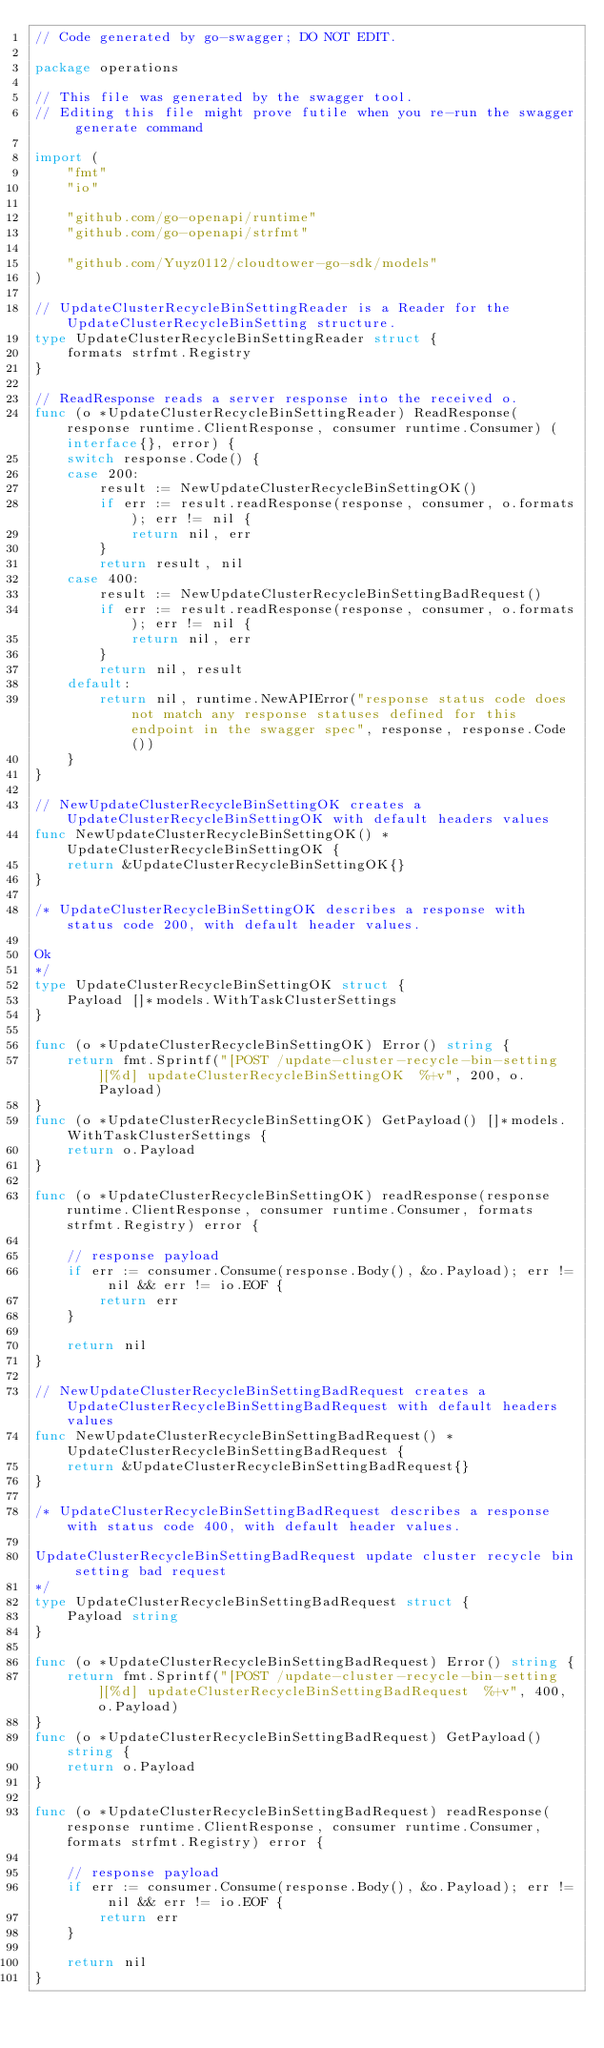<code> <loc_0><loc_0><loc_500><loc_500><_Go_>// Code generated by go-swagger; DO NOT EDIT.

package operations

// This file was generated by the swagger tool.
// Editing this file might prove futile when you re-run the swagger generate command

import (
	"fmt"
	"io"

	"github.com/go-openapi/runtime"
	"github.com/go-openapi/strfmt"

	"github.com/Yuyz0112/cloudtower-go-sdk/models"
)

// UpdateClusterRecycleBinSettingReader is a Reader for the UpdateClusterRecycleBinSetting structure.
type UpdateClusterRecycleBinSettingReader struct {
	formats strfmt.Registry
}

// ReadResponse reads a server response into the received o.
func (o *UpdateClusterRecycleBinSettingReader) ReadResponse(response runtime.ClientResponse, consumer runtime.Consumer) (interface{}, error) {
	switch response.Code() {
	case 200:
		result := NewUpdateClusterRecycleBinSettingOK()
		if err := result.readResponse(response, consumer, o.formats); err != nil {
			return nil, err
		}
		return result, nil
	case 400:
		result := NewUpdateClusterRecycleBinSettingBadRequest()
		if err := result.readResponse(response, consumer, o.formats); err != nil {
			return nil, err
		}
		return nil, result
	default:
		return nil, runtime.NewAPIError("response status code does not match any response statuses defined for this endpoint in the swagger spec", response, response.Code())
	}
}

// NewUpdateClusterRecycleBinSettingOK creates a UpdateClusterRecycleBinSettingOK with default headers values
func NewUpdateClusterRecycleBinSettingOK() *UpdateClusterRecycleBinSettingOK {
	return &UpdateClusterRecycleBinSettingOK{}
}

/* UpdateClusterRecycleBinSettingOK describes a response with status code 200, with default header values.

Ok
*/
type UpdateClusterRecycleBinSettingOK struct {
	Payload []*models.WithTaskClusterSettings
}

func (o *UpdateClusterRecycleBinSettingOK) Error() string {
	return fmt.Sprintf("[POST /update-cluster-recycle-bin-setting][%d] updateClusterRecycleBinSettingOK  %+v", 200, o.Payload)
}
func (o *UpdateClusterRecycleBinSettingOK) GetPayload() []*models.WithTaskClusterSettings {
	return o.Payload
}

func (o *UpdateClusterRecycleBinSettingOK) readResponse(response runtime.ClientResponse, consumer runtime.Consumer, formats strfmt.Registry) error {

	// response payload
	if err := consumer.Consume(response.Body(), &o.Payload); err != nil && err != io.EOF {
		return err
	}

	return nil
}

// NewUpdateClusterRecycleBinSettingBadRequest creates a UpdateClusterRecycleBinSettingBadRequest with default headers values
func NewUpdateClusterRecycleBinSettingBadRequest() *UpdateClusterRecycleBinSettingBadRequest {
	return &UpdateClusterRecycleBinSettingBadRequest{}
}

/* UpdateClusterRecycleBinSettingBadRequest describes a response with status code 400, with default header values.

UpdateClusterRecycleBinSettingBadRequest update cluster recycle bin setting bad request
*/
type UpdateClusterRecycleBinSettingBadRequest struct {
	Payload string
}

func (o *UpdateClusterRecycleBinSettingBadRequest) Error() string {
	return fmt.Sprintf("[POST /update-cluster-recycle-bin-setting][%d] updateClusterRecycleBinSettingBadRequest  %+v", 400, o.Payload)
}
func (o *UpdateClusterRecycleBinSettingBadRequest) GetPayload() string {
	return o.Payload
}

func (o *UpdateClusterRecycleBinSettingBadRequest) readResponse(response runtime.ClientResponse, consumer runtime.Consumer, formats strfmt.Registry) error {

	// response payload
	if err := consumer.Consume(response.Body(), &o.Payload); err != nil && err != io.EOF {
		return err
	}

	return nil
}
</code> 